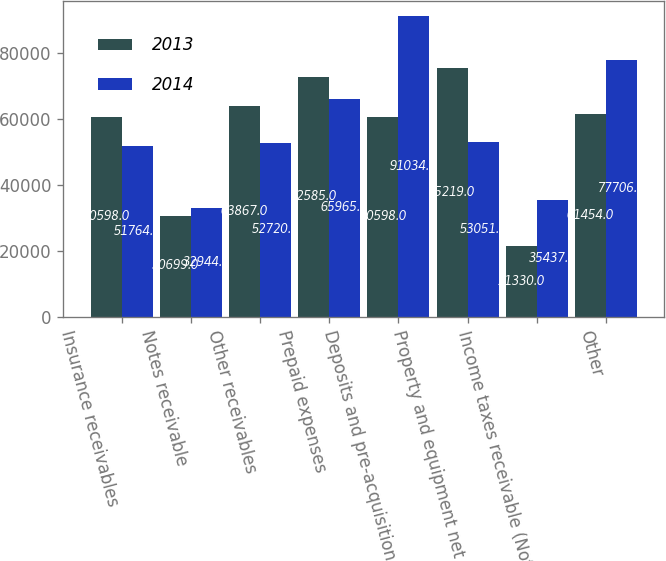Convert chart. <chart><loc_0><loc_0><loc_500><loc_500><stacked_bar_chart><ecel><fcel>Insurance receivables<fcel>Notes receivable<fcel>Other receivables<fcel>Prepaid expenses<fcel>Deposits and pre-acquisition<fcel>Property and equipment net<fcel>Income taxes receivable (Note<fcel>Other<nl><fcel>2013<fcel>60598<fcel>30699<fcel>63867<fcel>72585<fcel>60598<fcel>75219<fcel>21330<fcel>61454<nl><fcel>2014<fcel>51764<fcel>32944<fcel>52720<fcel>65965<fcel>91034<fcel>53051<fcel>35437<fcel>77706<nl></chart> 